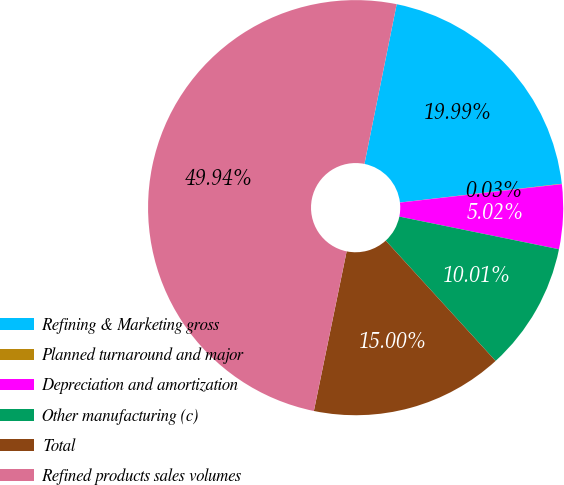Convert chart. <chart><loc_0><loc_0><loc_500><loc_500><pie_chart><fcel>Refining & Marketing gross<fcel>Planned turnaround and major<fcel>Depreciation and amortization<fcel>Other manufacturing (c)<fcel>Total<fcel>Refined products sales volumes<nl><fcel>19.99%<fcel>0.03%<fcel>5.02%<fcel>10.01%<fcel>15.0%<fcel>49.94%<nl></chart> 